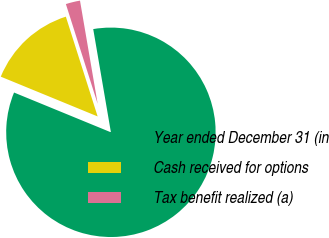Convert chart. <chart><loc_0><loc_0><loc_500><loc_500><pie_chart><fcel>Year ended December 31 (in<fcel>Cash received for options<fcel>Tax benefit realized (a)<nl><fcel>83.9%<fcel>13.89%<fcel>2.21%<nl></chart> 